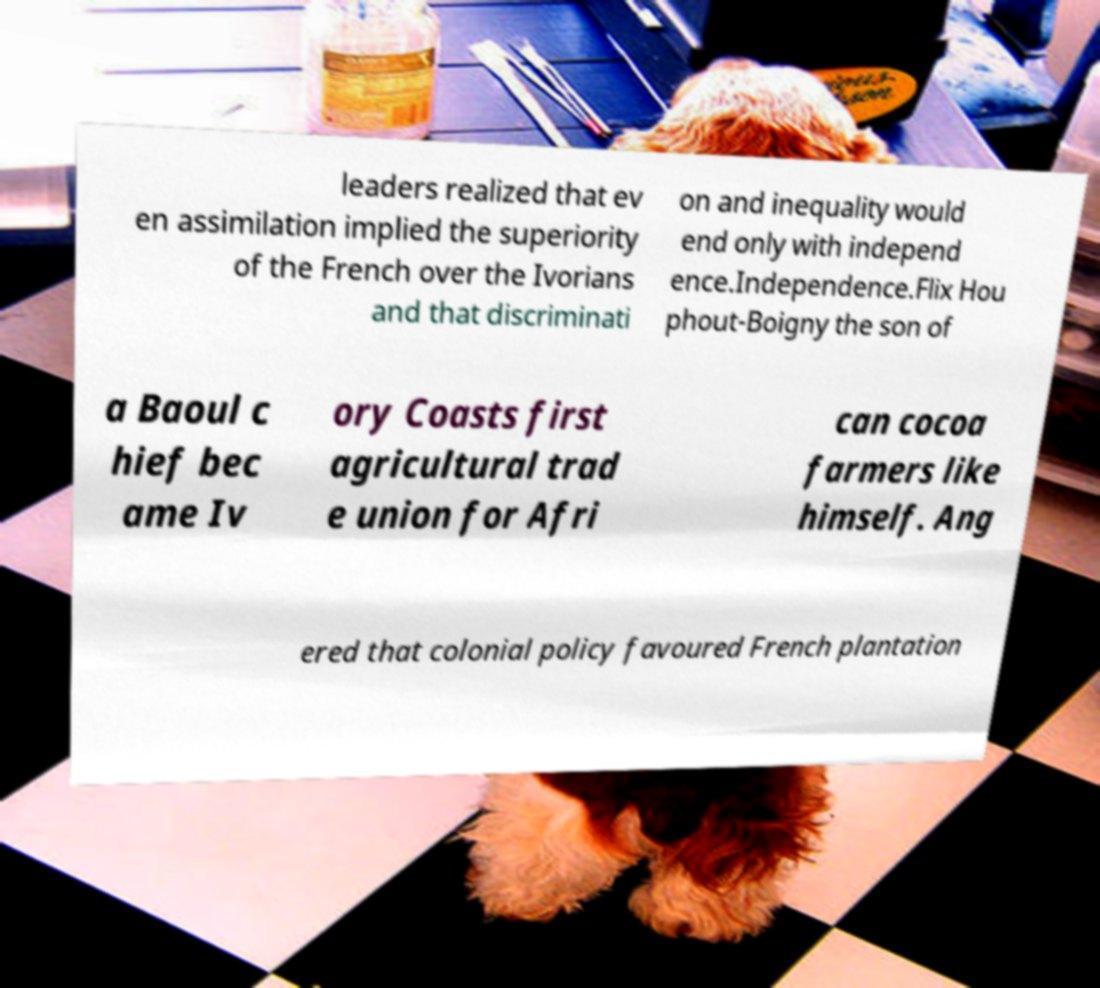Can you accurately transcribe the text from the provided image for me? leaders realized that ev en assimilation implied the superiority of the French over the Ivorians and that discriminati on and inequality would end only with independ ence.Independence.Flix Hou phout-Boigny the son of a Baoul c hief bec ame Iv ory Coasts first agricultural trad e union for Afri can cocoa farmers like himself. Ang ered that colonial policy favoured French plantation 